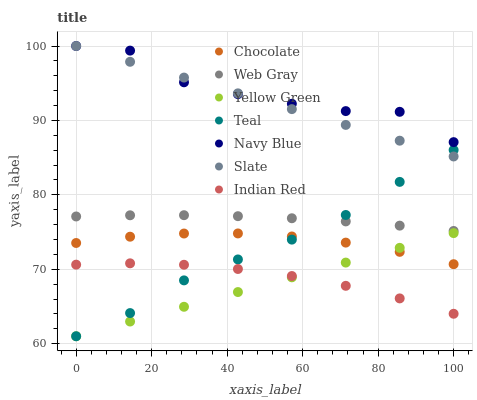Does Yellow Green have the minimum area under the curve?
Answer yes or no. Yes. Does Navy Blue have the maximum area under the curve?
Answer yes or no. Yes. Does Navy Blue have the minimum area under the curve?
Answer yes or no. No. Does Yellow Green have the maximum area under the curve?
Answer yes or no. No. Is Yellow Green the smoothest?
Answer yes or no. Yes. Is Navy Blue the roughest?
Answer yes or no. Yes. Is Navy Blue the smoothest?
Answer yes or no. No. Is Yellow Green the roughest?
Answer yes or no. No. Does Yellow Green have the lowest value?
Answer yes or no. Yes. Does Navy Blue have the lowest value?
Answer yes or no. No. Does Slate have the highest value?
Answer yes or no. Yes. Does Yellow Green have the highest value?
Answer yes or no. No. Is Web Gray less than Navy Blue?
Answer yes or no. Yes. Is Slate greater than Chocolate?
Answer yes or no. Yes. Does Teal intersect Yellow Green?
Answer yes or no. Yes. Is Teal less than Yellow Green?
Answer yes or no. No. Is Teal greater than Yellow Green?
Answer yes or no. No. Does Web Gray intersect Navy Blue?
Answer yes or no. No. 